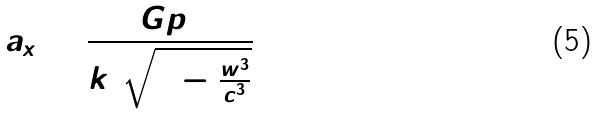Convert formula to latex. <formula><loc_0><loc_0><loc_500><loc_500>a _ { x } = \frac { G p _ { 5 } } { k ^ { 3 } \sqrt { 1 - \frac { w ^ { 3 } } { c ^ { 3 } } } }</formula> 